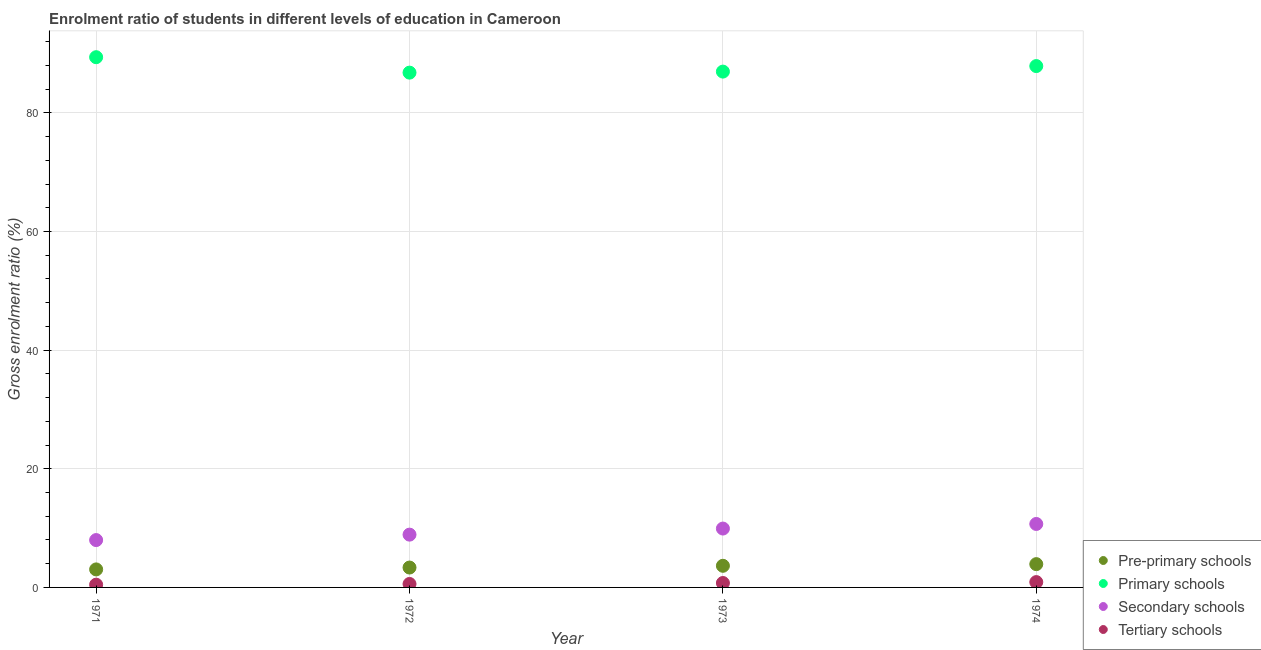What is the gross enrolment ratio in secondary schools in 1972?
Your answer should be very brief. 8.9. Across all years, what is the maximum gross enrolment ratio in secondary schools?
Provide a short and direct response. 10.7. Across all years, what is the minimum gross enrolment ratio in primary schools?
Keep it short and to the point. 86.78. In which year was the gross enrolment ratio in tertiary schools maximum?
Keep it short and to the point. 1974. What is the total gross enrolment ratio in pre-primary schools in the graph?
Provide a short and direct response. 13.96. What is the difference between the gross enrolment ratio in primary schools in 1971 and that in 1974?
Ensure brevity in your answer.  1.5. What is the difference between the gross enrolment ratio in secondary schools in 1974 and the gross enrolment ratio in pre-primary schools in 1971?
Make the answer very short. 7.66. What is the average gross enrolment ratio in pre-primary schools per year?
Keep it short and to the point. 3.49. In the year 1971, what is the difference between the gross enrolment ratio in primary schools and gross enrolment ratio in pre-primary schools?
Offer a terse response. 86.35. In how many years, is the gross enrolment ratio in primary schools greater than 20 %?
Offer a terse response. 4. What is the ratio of the gross enrolment ratio in pre-primary schools in 1971 to that in 1973?
Your answer should be very brief. 0.83. What is the difference between the highest and the second highest gross enrolment ratio in pre-primary schools?
Provide a succinct answer. 0.28. What is the difference between the highest and the lowest gross enrolment ratio in primary schools?
Your answer should be very brief. 2.6. In how many years, is the gross enrolment ratio in secondary schools greater than the average gross enrolment ratio in secondary schools taken over all years?
Provide a succinct answer. 2. Is it the case that in every year, the sum of the gross enrolment ratio in pre-primary schools and gross enrolment ratio in primary schools is greater than the gross enrolment ratio in secondary schools?
Ensure brevity in your answer.  Yes. Does the gross enrolment ratio in tertiary schools monotonically increase over the years?
Ensure brevity in your answer.  Yes. Is the gross enrolment ratio in primary schools strictly greater than the gross enrolment ratio in pre-primary schools over the years?
Your answer should be compact. Yes. Is the gross enrolment ratio in primary schools strictly less than the gross enrolment ratio in tertiary schools over the years?
Ensure brevity in your answer.  No. How many years are there in the graph?
Provide a short and direct response. 4. Does the graph contain grids?
Make the answer very short. Yes. How many legend labels are there?
Provide a short and direct response. 4. What is the title of the graph?
Offer a terse response. Enrolment ratio of students in different levels of education in Cameroon. Does "Negligence towards children" appear as one of the legend labels in the graph?
Keep it short and to the point. No. What is the label or title of the Y-axis?
Offer a very short reply. Gross enrolment ratio (%). What is the Gross enrolment ratio (%) in Pre-primary schools in 1971?
Ensure brevity in your answer.  3.04. What is the Gross enrolment ratio (%) in Primary schools in 1971?
Make the answer very short. 89.38. What is the Gross enrolment ratio (%) in Secondary schools in 1971?
Your answer should be compact. 7.98. What is the Gross enrolment ratio (%) of Tertiary schools in 1971?
Offer a terse response. 0.46. What is the Gross enrolment ratio (%) of Pre-primary schools in 1972?
Give a very brief answer. 3.35. What is the Gross enrolment ratio (%) in Primary schools in 1972?
Give a very brief answer. 86.78. What is the Gross enrolment ratio (%) of Secondary schools in 1972?
Provide a succinct answer. 8.9. What is the Gross enrolment ratio (%) in Tertiary schools in 1972?
Your answer should be very brief. 0.58. What is the Gross enrolment ratio (%) in Pre-primary schools in 1973?
Give a very brief answer. 3.65. What is the Gross enrolment ratio (%) in Primary schools in 1973?
Provide a succinct answer. 86.95. What is the Gross enrolment ratio (%) in Secondary schools in 1973?
Your answer should be very brief. 9.92. What is the Gross enrolment ratio (%) of Tertiary schools in 1973?
Make the answer very short. 0.74. What is the Gross enrolment ratio (%) in Pre-primary schools in 1974?
Provide a succinct answer. 3.93. What is the Gross enrolment ratio (%) in Primary schools in 1974?
Your answer should be very brief. 87.89. What is the Gross enrolment ratio (%) in Secondary schools in 1974?
Provide a short and direct response. 10.7. What is the Gross enrolment ratio (%) of Tertiary schools in 1974?
Make the answer very short. 0.9. Across all years, what is the maximum Gross enrolment ratio (%) in Pre-primary schools?
Give a very brief answer. 3.93. Across all years, what is the maximum Gross enrolment ratio (%) in Primary schools?
Your answer should be very brief. 89.38. Across all years, what is the maximum Gross enrolment ratio (%) in Secondary schools?
Your answer should be very brief. 10.7. Across all years, what is the maximum Gross enrolment ratio (%) in Tertiary schools?
Ensure brevity in your answer.  0.9. Across all years, what is the minimum Gross enrolment ratio (%) in Pre-primary schools?
Your answer should be very brief. 3.04. Across all years, what is the minimum Gross enrolment ratio (%) in Primary schools?
Make the answer very short. 86.78. Across all years, what is the minimum Gross enrolment ratio (%) of Secondary schools?
Your answer should be compact. 7.98. Across all years, what is the minimum Gross enrolment ratio (%) of Tertiary schools?
Your answer should be compact. 0.46. What is the total Gross enrolment ratio (%) in Pre-primary schools in the graph?
Offer a very short reply. 13.96. What is the total Gross enrolment ratio (%) of Primary schools in the graph?
Your response must be concise. 351. What is the total Gross enrolment ratio (%) in Secondary schools in the graph?
Ensure brevity in your answer.  37.5. What is the total Gross enrolment ratio (%) of Tertiary schools in the graph?
Give a very brief answer. 2.69. What is the difference between the Gross enrolment ratio (%) of Pre-primary schools in 1971 and that in 1972?
Your answer should be very brief. -0.31. What is the difference between the Gross enrolment ratio (%) in Primary schools in 1971 and that in 1972?
Ensure brevity in your answer.  2.6. What is the difference between the Gross enrolment ratio (%) in Secondary schools in 1971 and that in 1972?
Give a very brief answer. -0.92. What is the difference between the Gross enrolment ratio (%) in Tertiary schools in 1971 and that in 1972?
Provide a succinct answer. -0.12. What is the difference between the Gross enrolment ratio (%) of Pre-primary schools in 1971 and that in 1973?
Keep it short and to the point. -0.61. What is the difference between the Gross enrolment ratio (%) of Primary schools in 1971 and that in 1973?
Keep it short and to the point. 2.43. What is the difference between the Gross enrolment ratio (%) of Secondary schools in 1971 and that in 1973?
Offer a terse response. -1.94. What is the difference between the Gross enrolment ratio (%) in Tertiary schools in 1971 and that in 1973?
Your answer should be very brief. -0.28. What is the difference between the Gross enrolment ratio (%) of Pre-primary schools in 1971 and that in 1974?
Make the answer very short. -0.89. What is the difference between the Gross enrolment ratio (%) in Primary schools in 1971 and that in 1974?
Your response must be concise. 1.5. What is the difference between the Gross enrolment ratio (%) in Secondary schools in 1971 and that in 1974?
Provide a succinct answer. -2.72. What is the difference between the Gross enrolment ratio (%) in Tertiary schools in 1971 and that in 1974?
Your response must be concise. -0.43. What is the difference between the Gross enrolment ratio (%) of Pre-primary schools in 1972 and that in 1973?
Ensure brevity in your answer.  -0.29. What is the difference between the Gross enrolment ratio (%) of Primary schools in 1972 and that in 1973?
Provide a short and direct response. -0.18. What is the difference between the Gross enrolment ratio (%) in Secondary schools in 1972 and that in 1973?
Offer a very short reply. -1.02. What is the difference between the Gross enrolment ratio (%) in Tertiary schools in 1972 and that in 1973?
Ensure brevity in your answer.  -0.16. What is the difference between the Gross enrolment ratio (%) of Pre-primary schools in 1972 and that in 1974?
Keep it short and to the point. -0.57. What is the difference between the Gross enrolment ratio (%) in Primary schools in 1972 and that in 1974?
Give a very brief answer. -1.11. What is the difference between the Gross enrolment ratio (%) of Secondary schools in 1972 and that in 1974?
Provide a short and direct response. -1.8. What is the difference between the Gross enrolment ratio (%) of Tertiary schools in 1972 and that in 1974?
Provide a short and direct response. -0.32. What is the difference between the Gross enrolment ratio (%) in Pre-primary schools in 1973 and that in 1974?
Provide a short and direct response. -0.28. What is the difference between the Gross enrolment ratio (%) of Primary schools in 1973 and that in 1974?
Offer a very short reply. -0.93. What is the difference between the Gross enrolment ratio (%) of Secondary schools in 1973 and that in 1974?
Your answer should be compact. -0.77. What is the difference between the Gross enrolment ratio (%) in Tertiary schools in 1973 and that in 1974?
Offer a very short reply. -0.15. What is the difference between the Gross enrolment ratio (%) of Pre-primary schools in 1971 and the Gross enrolment ratio (%) of Primary schools in 1972?
Offer a terse response. -83.74. What is the difference between the Gross enrolment ratio (%) in Pre-primary schools in 1971 and the Gross enrolment ratio (%) in Secondary schools in 1972?
Ensure brevity in your answer.  -5.86. What is the difference between the Gross enrolment ratio (%) of Pre-primary schools in 1971 and the Gross enrolment ratio (%) of Tertiary schools in 1972?
Provide a succinct answer. 2.45. What is the difference between the Gross enrolment ratio (%) in Primary schools in 1971 and the Gross enrolment ratio (%) in Secondary schools in 1972?
Provide a succinct answer. 80.48. What is the difference between the Gross enrolment ratio (%) in Primary schools in 1971 and the Gross enrolment ratio (%) in Tertiary schools in 1972?
Make the answer very short. 88.8. What is the difference between the Gross enrolment ratio (%) of Secondary schools in 1971 and the Gross enrolment ratio (%) of Tertiary schools in 1972?
Keep it short and to the point. 7.4. What is the difference between the Gross enrolment ratio (%) of Pre-primary schools in 1971 and the Gross enrolment ratio (%) of Primary schools in 1973?
Provide a succinct answer. -83.92. What is the difference between the Gross enrolment ratio (%) in Pre-primary schools in 1971 and the Gross enrolment ratio (%) in Secondary schools in 1973?
Your answer should be compact. -6.89. What is the difference between the Gross enrolment ratio (%) of Pre-primary schools in 1971 and the Gross enrolment ratio (%) of Tertiary schools in 1973?
Ensure brevity in your answer.  2.29. What is the difference between the Gross enrolment ratio (%) of Primary schools in 1971 and the Gross enrolment ratio (%) of Secondary schools in 1973?
Your answer should be very brief. 79.46. What is the difference between the Gross enrolment ratio (%) in Primary schools in 1971 and the Gross enrolment ratio (%) in Tertiary schools in 1973?
Make the answer very short. 88.64. What is the difference between the Gross enrolment ratio (%) in Secondary schools in 1971 and the Gross enrolment ratio (%) in Tertiary schools in 1973?
Give a very brief answer. 7.24. What is the difference between the Gross enrolment ratio (%) of Pre-primary schools in 1971 and the Gross enrolment ratio (%) of Primary schools in 1974?
Provide a short and direct response. -84.85. What is the difference between the Gross enrolment ratio (%) in Pre-primary schools in 1971 and the Gross enrolment ratio (%) in Secondary schools in 1974?
Provide a succinct answer. -7.66. What is the difference between the Gross enrolment ratio (%) in Pre-primary schools in 1971 and the Gross enrolment ratio (%) in Tertiary schools in 1974?
Your answer should be very brief. 2.14. What is the difference between the Gross enrolment ratio (%) in Primary schools in 1971 and the Gross enrolment ratio (%) in Secondary schools in 1974?
Provide a succinct answer. 78.68. What is the difference between the Gross enrolment ratio (%) in Primary schools in 1971 and the Gross enrolment ratio (%) in Tertiary schools in 1974?
Keep it short and to the point. 88.48. What is the difference between the Gross enrolment ratio (%) of Secondary schools in 1971 and the Gross enrolment ratio (%) of Tertiary schools in 1974?
Your answer should be very brief. 7.08. What is the difference between the Gross enrolment ratio (%) in Pre-primary schools in 1972 and the Gross enrolment ratio (%) in Primary schools in 1973?
Provide a succinct answer. -83.6. What is the difference between the Gross enrolment ratio (%) of Pre-primary schools in 1972 and the Gross enrolment ratio (%) of Secondary schools in 1973?
Give a very brief answer. -6.57. What is the difference between the Gross enrolment ratio (%) in Pre-primary schools in 1972 and the Gross enrolment ratio (%) in Tertiary schools in 1973?
Keep it short and to the point. 2.61. What is the difference between the Gross enrolment ratio (%) in Primary schools in 1972 and the Gross enrolment ratio (%) in Secondary schools in 1973?
Ensure brevity in your answer.  76.86. What is the difference between the Gross enrolment ratio (%) in Primary schools in 1972 and the Gross enrolment ratio (%) in Tertiary schools in 1973?
Your response must be concise. 86.04. What is the difference between the Gross enrolment ratio (%) of Secondary schools in 1972 and the Gross enrolment ratio (%) of Tertiary schools in 1973?
Provide a succinct answer. 8.15. What is the difference between the Gross enrolment ratio (%) in Pre-primary schools in 1972 and the Gross enrolment ratio (%) in Primary schools in 1974?
Your answer should be very brief. -84.53. What is the difference between the Gross enrolment ratio (%) in Pre-primary schools in 1972 and the Gross enrolment ratio (%) in Secondary schools in 1974?
Offer a terse response. -7.35. What is the difference between the Gross enrolment ratio (%) of Pre-primary schools in 1972 and the Gross enrolment ratio (%) of Tertiary schools in 1974?
Provide a short and direct response. 2.45. What is the difference between the Gross enrolment ratio (%) in Primary schools in 1972 and the Gross enrolment ratio (%) in Secondary schools in 1974?
Your response must be concise. 76.08. What is the difference between the Gross enrolment ratio (%) of Primary schools in 1972 and the Gross enrolment ratio (%) of Tertiary schools in 1974?
Make the answer very short. 85.88. What is the difference between the Gross enrolment ratio (%) of Secondary schools in 1972 and the Gross enrolment ratio (%) of Tertiary schools in 1974?
Give a very brief answer. 8. What is the difference between the Gross enrolment ratio (%) in Pre-primary schools in 1973 and the Gross enrolment ratio (%) in Primary schools in 1974?
Your answer should be compact. -84.24. What is the difference between the Gross enrolment ratio (%) in Pre-primary schools in 1973 and the Gross enrolment ratio (%) in Secondary schools in 1974?
Give a very brief answer. -7.05. What is the difference between the Gross enrolment ratio (%) in Pre-primary schools in 1973 and the Gross enrolment ratio (%) in Tertiary schools in 1974?
Keep it short and to the point. 2.75. What is the difference between the Gross enrolment ratio (%) in Primary schools in 1973 and the Gross enrolment ratio (%) in Secondary schools in 1974?
Offer a very short reply. 76.26. What is the difference between the Gross enrolment ratio (%) of Primary schools in 1973 and the Gross enrolment ratio (%) of Tertiary schools in 1974?
Your answer should be compact. 86.06. What is the difference between the Gross enrolment ratio (%) of Secondary schools in 1973 and the Gross enrolment ratio (%) of Tertiary schools in 1974?
Keep it short and to the point. 9.02. What is the average Gross enrolment ratio (%) in Pre-primary schools per year?
Your answer should be very brief. 3.49. What is the average Gross enrolment ratio (%) in Primary schools per year?
Your answer should be very brief. 87.75. What is the average Gross enrolment ratio (%) in Secondary schools per year?
Your response must be concise. 9.38. What is the average Gross enrolment ratio (%) in Tertiary schools per year?
Ensure brevity in your answer.  0.67. In the year 1971, what is the difference between the Gross enrolment ratio (%) of Pre-primary schools and Gross enrolment ratio (%) of Primary schools?
Provide a short and direct response. -86.35. In the year 1971, what is the difference between the Gross enrolment ratio (%) in Pre-primary schools and Gross enrolment ratio (%) in Secondary schools?
Offer a very short reply. -4.95. In the year 1971, what is the difference between the Gross enrolment ratio (%) in Pre-primary schools and Gross enrolment ratio (%) in Tertiary schools?
Offer a very short reply. 2.57. In the year 1971, what is the difference between the Gross enrolment ratio (%) in Primary schools and Gross enrolment ratio (%) in Secondary schools?
Make the answer very short. 81.4. In the year 1971, what is the difference between the Gross enrolment ratio (%) in Primary schools and Gross enrolment ratio (%) in Tertiary schools?
Offer a very short reply. 88.92. In the year 1971, what is the difference between the Gross enrolment ratio (%) of Secondary schools and Gross enrolment ratio (%) of Tertiary schools?
Offer a terse response. 7.52. In the year 1972, what is the difference between the Gross enrolment ratio (%) in Pre-primary schools and Gross enrolment ratio (%) in Primary schools?
Keep it short and to the point. -83.43. In the year 1972, what is the difference between the Gross enrolment ratio (%) in Pre-primary schools and Gross enrolment ratio (%) in Secondary schools?
Make the answer very short. -5.55. In the year 1972, what is the difference between the Gross enrolment ratio (%) of Pre-primary schools and Gross enrolment ratio (%) of Tertiary schools?
Offer a terse response. 2.77. In the year 1972, what is the difference between the Gross enrolment ratio (%) in Primary schools and Gross enrolment ratio (%) in Secondary schools?
Your answer should be very brief. 77.88. In the year 1972, what is the difference between the Gross enrolment ratio (%) of Primary schools and Gross enrolment ratio (%) of Tertiary schools?
Give a very brief answer. 86.2. In the year 1972, what is the difference between the Gross enrolment ratio (%) of Secondary schools and Gross enrolment ratio (%) of Tertiary schools?
Provide a short and direct response. 8.32. In the year 1973, what is the difference between the Gross enrolment ratio (%) of Pre-primary schools and Gross enrolment ratio (%) of Primary schools?
Ensure brevity in your answer.  -83.31. In the year 1973, what is the difference between the Gross enrolment ratio (%) in Pre-primary schools and Gross enrolment ratio (%) in Secondary schools?
Your response must be concise. -6.28. In the year 1973, what is the difference between the Gross enrolment ratio (%) of Pre-primary schools and Gross enrolment ratio (%) of Tertiary schools?
Make the answer very short. 2.9. In the year 1973, what is the difference between the Gross enrolment ratio (%) in Primary schools and Gross enrolment ratio (%) in Secondary schools?
Your response must be concise. 77.03. In the year 1973, what is the difference between the Gross enrolment ratio (%) in Primary schools and Gross enrolment ratio (%) in Tertiary schools?
Keep it short and to the point. 86.21. In the year 1973, what is the difference between the Gross enrolment ratio (%) in Secondary schools and Gross enrolment ratio (%) in Tertiary schools?
Provide a succinct answer. 9.18. In the year 1974, what is the difference between the Gross enrolment ratio (%) of Pre-primary schools and Gross enrolment ratio (%) of Primary schools?
Provide a short and direct response. -83.96. In the year 1974, what is the difference between the Gross enrolment ratio (%) in Pre-primary schools and Gross enrolment ratio (%) in Secondary schools?
Your response must be concise. -6.77. In the year 1974, what is the difference between the Gross enrolment ratio (%) in Pre-primary schools and Gross enrolment ratio (%) in Tertiary schools?
Ensure brevity in your answer.  3.03. In the year 1974, what is the difference between the Gross enrolment ratio (%) in Primary schools and Gross enrolment ratio (%) in Secondary schools?
Provide a short and direct response. 77.19. In the year 1974, what is the difference between the Gross enrolment ratio (%) of Primary schools and Gross enrolment ratio (%) of Tertiary schools?
Keep it short and to the point. 86.99. In the year 1974, what is the difference between the Gross enrolment ratio (%) of Secondary schools and Gross enrolment ratio (%) of Tertiary schools?
Keep it short and to the point. 9.8. What is the ratio of the Gross enrolment ratio (%) in Pre-primary schools in 1971 to that in 1972?
Provide a short and direct response. 0.91. What is the ratio of the Gross enrolment ratio (%) of Primary schools in 1971 to that in 1972?
Offer a terse response. 1.03. What is the ratio of the Gross enrolment ratio (%) of Secondary schools in 1971 to that in 1972?
Your response must be concise. 0.9. What is the ratio of the Gross enrolment ratio (%) of Tertiary schools in 1971 to that in 1972?
Ensure brevity in your answer.  0.8. What is the ratio of the Gross enrolment ratio (%) in Pre-primary schools in 1971 to that in 1973?
Your response must be concise. 0.83. What is the ratio of the Gross enrolment ratio (%) in Primary schools in 1971 to that in 1973?
Your response must be concise. 1.03. What is the ratio of the Gross enrolment ratio (%) in Secondary schools in 1971 to that in 1973?
Your response must be concise. 0.8. What is the ratio of the Gross enrolment ratio (%) in Tertiary schools in 1971 to that in 1973?
Your response must be concise. 0.62. What is the ratio of the Gross enrolment ratio (%) in Pre-primary schools in 1971 to that in 1974?
Your answer should be compact. 0.77. What is the ratio of the Gross enrolment ratio (%) of Secondary schools in 1971 to that in 1974?
Give a very brief answer. 0.75. What is the ratio of the Gross enrolment ratio (%) in Tertiary schools in 1971 to that in 1974?
Provide a succinct answer. 0.52. What is the ratio of the Gross enrolment ratio (%) in Pre-primary schools in 1972 to that in 1973?
Provide a short and direct response. 0.92. What is the ratio of the Gross enrolment ratio (%) of Secondary schools in 1972 to that in 1973?
Provide a succinct answer. 0.9. What is the ratio of the Gross enrolment ratio (%) of Tertiary schools in 1972 to that in 1973?
Give a very brief answer. 0.78. What is the ratio of the Gross enrolment ratio (%) in Pre-primary schools in 1972 to that in 1974?
Offer a terse response. 0.85. What is the ratio of the Gross enrolment ratio (%) in Primary schools in 1972 to that in 1974?
Give a very brief answer. 0.99. What is the ratio of the Gross enrolment ratio (%) of Secondary schools in 1972 to that in 1974?
Your response must be concise. 0.83. What is the ratio of the Gross enrolment ratio (%) in Tertiary schools in 1972 to that in 1974?
Make the answer very short. 0.65. What is the ratio of the Gross enrolment ratio (%) in Pre-primary schools in 1973 to that in 1974?
Ensure brevity in your answer.  0.93. What is the ratio of the Gross enrolment ratio (%) in Primary schools in 1973 to that in 1974?
Give a very brief answer. 0.99. What is the ratio of the Gross enrolment ratio (%) of Secondary schools in 1973 to that in 1974?
Your response must be concise. 0.93. What is the ratio of the Gross enrolment ratio (%) in Tertiary schools in 1973 to that in 1974?
Provide a succinct answer. 0.83. What is the difference between the highest and the second highest Gross enrolment ratio (%) in Pre-primary schools?
Keep it short and to the point. 0.28. What is the difference between the highest and the second highest Gross enrolment ratio (%) in Primary schools?
Your answer should be very brief. 1.5. What is the difference between the highest and the second highest Gross enrolment ratio (%) in Secondary schools?
Offer a terse response. 0.77. What is the difference between the highest and the second highest Gross enrolment ratio (%) in Tertiary schools?
Provide a succinct answer. 0.15. What is the difference between the highest and the lowest Gross enrolment ratio (%) of Pre-primary schools?
Make the answer very short. 0.89. What is the difference between the highest and the lowest Gross enrolment ratio (%) in Primary schools?
Your answer should be very brief. 2.6. What is the difference between the highest and the lowest Gross enrolment ratio (%) in Secondary schools?
Provide a succinct answer. 2.72. What is the difference between the highest and the lowest Gross enrolment ratio (%) in Tertiary schools?
Keep it short and to the point. 0.43. 